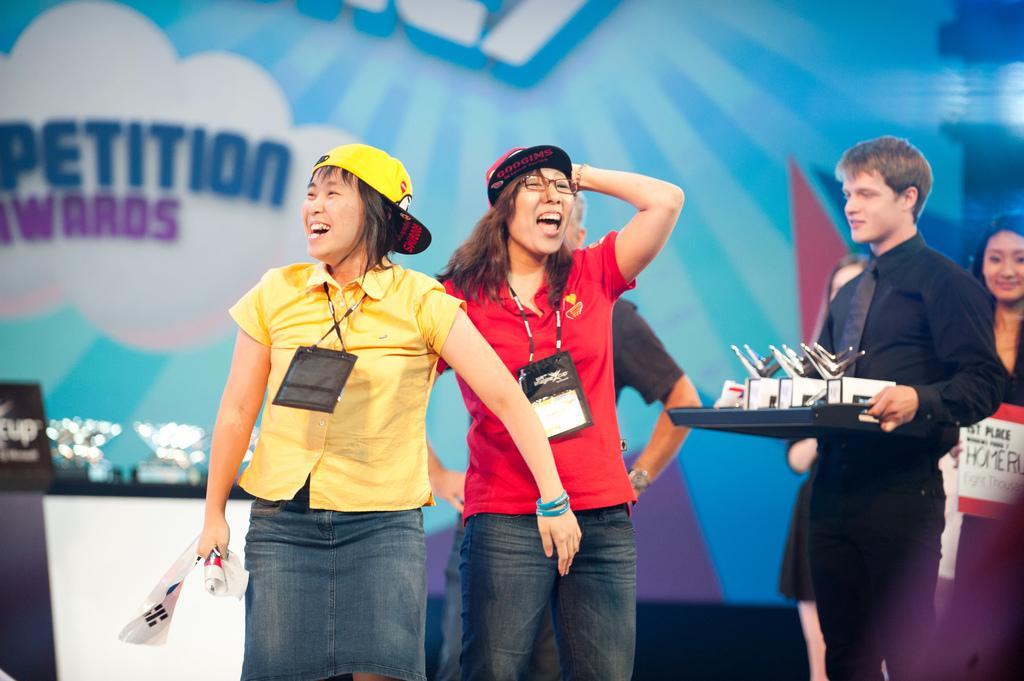In one or two sentences, can you explain what this image depicts? In this image we can see a group of people standing. In that a woman is holding a cloth and a man is holding a tray containing some objects in it. On the backside we can see a board and some objects on a table and a banner with some text on it. 